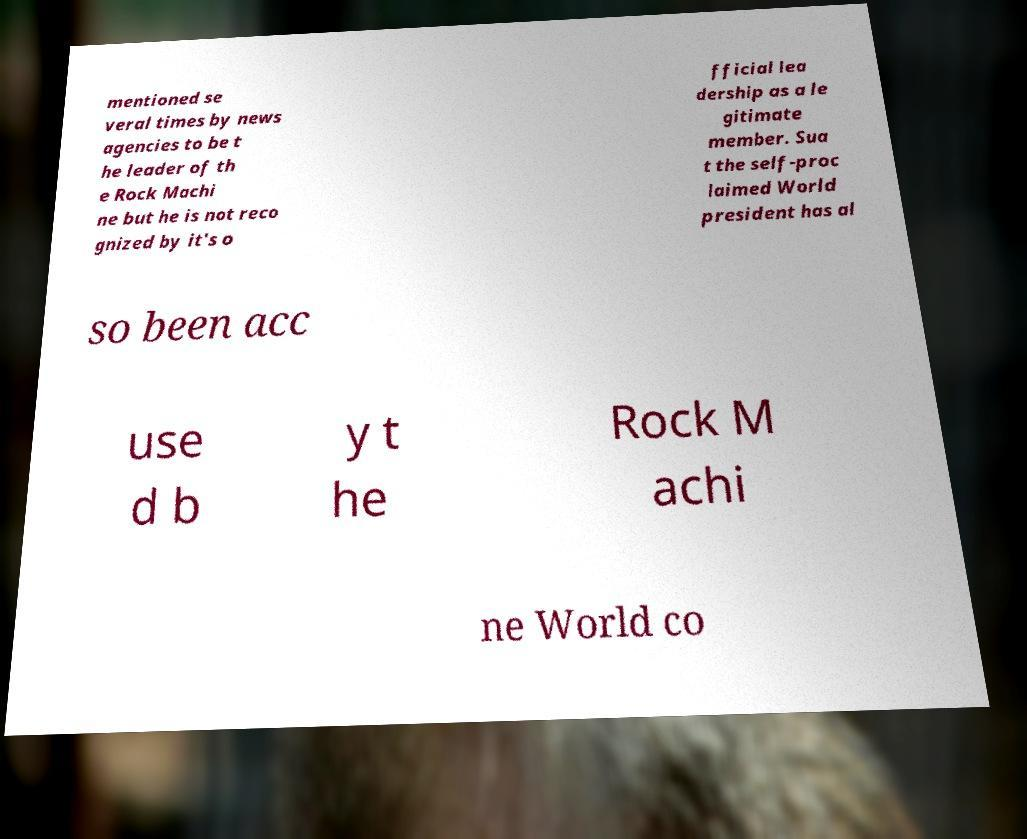Please identify and transcribe the text found in this image. mentioned se veral times by news agencies to be t he leader of th e Rock Machi ne but he is not reco gnized by it's o fficial lea dership as a le gitimate member. Sua t the self-proc laimed World president has al so been acc use d b y t he Rock M achi ne World co 